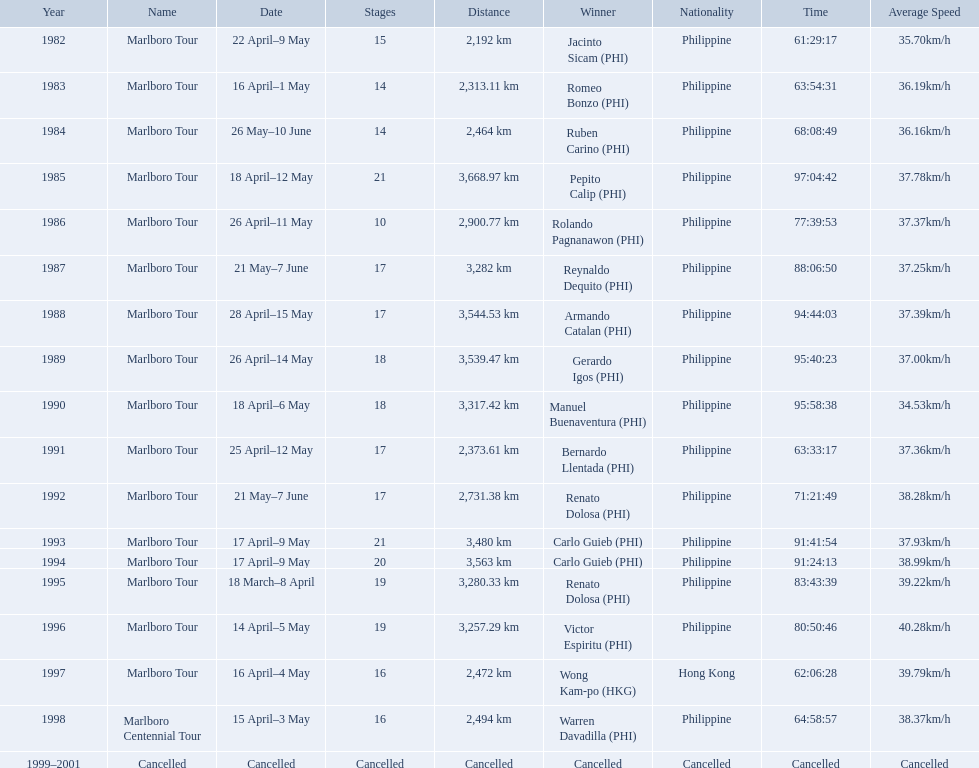What were the tour names during le tour de filipinas? Marlboro Tour, Marlboro Tour, Marlboro Tour, Marlboro Tour, Marlboro Tour, Marlboro Tour, Marlboro Tour, Marlboro Tour, Marlboro Tour, Marlboro Tour, Marlboro Tour, Marlboro Tour, Marlboro Tour, Marlboro Tour, Marlboro Tour, Marlboro Tour, Marlboro Centennial Tour, Cancelled. What were the recorded distances for each marlboro tour? 2,192 km, 2,313.11 km, 2,464 km, 3,668.97 km, 2,900.77 km, 3,282 km, 3,544.53 km, 3,539.47 km, 3,317.42 km, 2,373.61 km, 2,731.38 km, 3,480 km, 3,563 km, 3,280.33 km, 3,257.29 km, 2,472 km. And of those distances, which was the longest? 3,668.97 km. How far did the marlboro tour travel each year? 2,192 km, 2,313.11 km, 2,464 km, 3,668.97 km, 2,900.77 km, 3,282 km, 3,544.53 km, 3,539.47 km, 3,317.42 km, 2,373.61 km, 2,731.38 km, 3,480 km, 3,563 km, 3,280.33 km, 3,257.29 km, 2,472 km, 2,494 km, Cancelled. In what year did they travel the furthest? 1985. How far did they travel that year? 3,668.97 km. What race did warren davadilla compete in in 1998? Marlboro Centennial Tour. How long did it take davadilla to complete the marlboro centennial tour? 64:58:57. Write the full table. {'header': ['Year', 'Name', 'Date', 'Stages', 'Distance', 'Winner', 'Nationality', 'Time', 'Average Speed'], 'rows': [['1982', 'Marlboro Tour', '22 April–9 May', '15', '2,192\xa0km', 'Jacinto Sicam\xa0(PHI)', 'Philippine', '61:29:17', '35.70km/h'], ['1983', 'Marlboro Tour', '16 April–1 May', '14', '2,313.11\xa0km', 'Romeo Bonzo\xa0(PHI)', 'Philippine', '63:54:31', '36.19km/h'], ['1984', 'Marlboro Tour', '26 May–10 June', '14', '2,464\xa0km', 'Ruben Carino\xa0(PHI)', 'Philippine', '68:08:49', '36.16km/h'], ['1985', 'Marlboro Tour', '18 April–12 May', '21', '3,668.97\xa0km', 'Pepito Calip\xa0(PHI)', 'Philippine', '97:04:42', '37.78km/h'], ['1986', 'Marlboro Tour', '26 April–11 May', '10', '2,900.77\xa0km', 'Rolando Pagnanawon\xa0(PHI)', 'Philippine', '77:39:53', '37.37km/h'], ['1987', 'Marlboro Tour', '21 May–7 June', '17', '3,282\xa0km', 'Reynaldo Dequito\xa0(PHI)', 'Philippine', '88:06:50', '37.25km/h'], ['1988', 'Marlboro Tour', '28 April–15 May', '17', '3,544.53\xa0km', 'Armando Catalan\xa0(PHI)', 'Philippine', '94:44:03', '37.39km/h'], ['1989', 'Marlboro Tour', '26 April–14 May', '18', '3,539.47\xa0km', 'Gerardo Igos\xa0(PHI)', 'Philippine', '95:40:23', '37.00km/h'], ['1990', 'Marlboro Tour', '18 April–6 May', '18', '3,317.42\xa0km', 'Manuel Buenaventura\xa0(PHI)', 'Philippine', '95:58:38', '34.53km/h'], ['1991', 'Marlboro Tour', '25 April–12 May', '17', '2,373.61\xa0km', 'Bernardo Llentada\xa0(PHI)', 'Philippine', '63:33:17', '37.36km/h'], ['1992', 'Marlboro Tour', '21 May–7 June', '17', '2,731.38\xa0km', 'Renato Dolosa\xa0(PHI)', 'Philippine', '71:21:49', '38.28km/h'], ['1993', 'Marlboro Tour', '17 April–9 May', '21', '3,480\xa0km', 'Carlo Guieb\xa0(PHI)', 'Philippine', '91:41:54', '37.93km/h'], ['1994', 'Marlboro Tour', '17 April–9 May', '20', '3,563\xa0km', 'Carlo Guieb\xa0(PHI)', 'Philippine', '91:24:13', '38.99km/h'], ['1995', 'Marlboro Tour', '18 March–8 April', '19', '3,280.33\xa0km', 'Renato Dolosa\xa0(PHI)', 'Philippine', '83:43:39', '39.22km/h'], ['1996', 'Marlboro Tour', '14 April–5 May', '19', '3,257.29\xa0km', 'Victor Espiritu\xa0(PHI)', 'Philippine', '80:50:46', '40.28km/h'], ['1997', 'Marlboro Tour', '16 April–4 May', '16', '2,472\xa0km', 'Wong Kam-po\xa0(HKG)', 'Hong Kong', '62:06:28', '39.79km/h'], ['1998', 'Marlboro Centennial Tour', '15 April–3 May', '16', '2,494\xa0km', 'Warren Davadilla\xa0(PHI)', 'Philippine', '64:58:57', '38.37km/h'], ['1999–2001', 'Cancelled', 'Cancelled', 'Cancelled', 'Cancelled', 'Cancelled', 'Cancelled', 'Cancelled', 'Cancelled']]} 